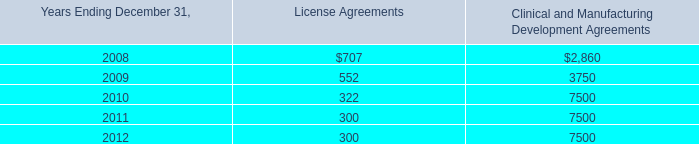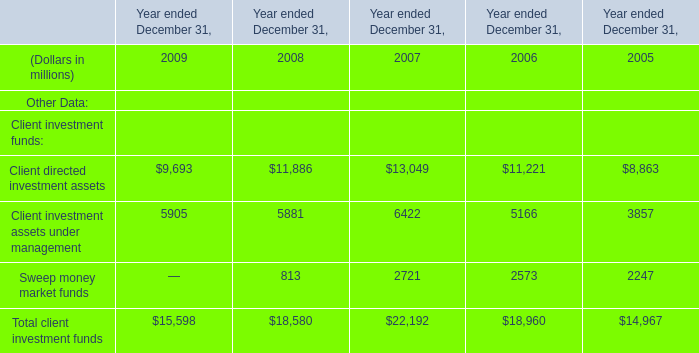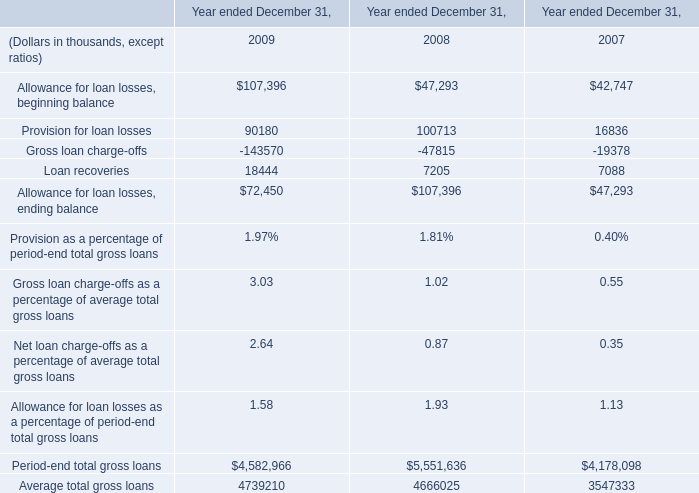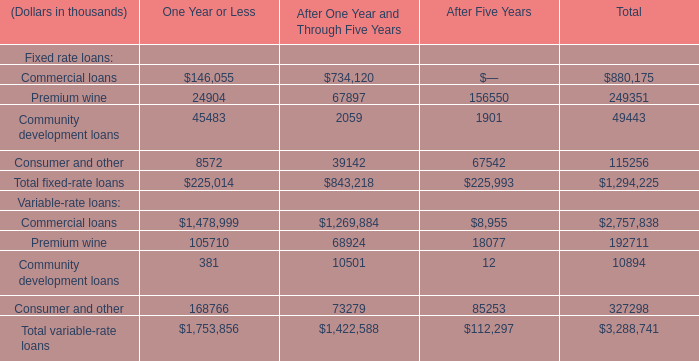What is the sum of Commercial loans of One Year or Less, and Loan recoveries of Year ended December 31, 2009 ? 
Computations: (146055.0 + 18444.0)
Answer: 164499.0. 